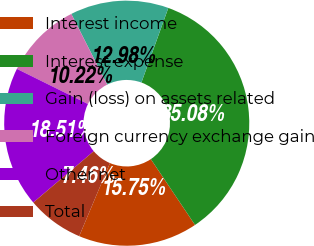Convert chart. <chart><loc_0><loc_0><loc_500><loc_500><pie_chart><fcel>Interest income<fcel>Interest expense<fcel>Gain (loss) on assets related<fcel>Foreign currency exchange gain<fcel>Other net<fcel>Total<nl><fcel>15.75%<fcel>35.08%<fcel>12.98%<fcel>10.22%<fcel>18.51%<fcel>7.46%<nl></chart> 